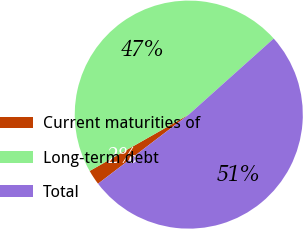<chart> <loc_0><loc_0><loc_500><loc_500><pie_chart><fcel>Current maturities of<fcel>Long-term debt<fcel>Total<nl><fcel>2.13%<fcel>46.61%<fcel>51.27%<nl></chart> 